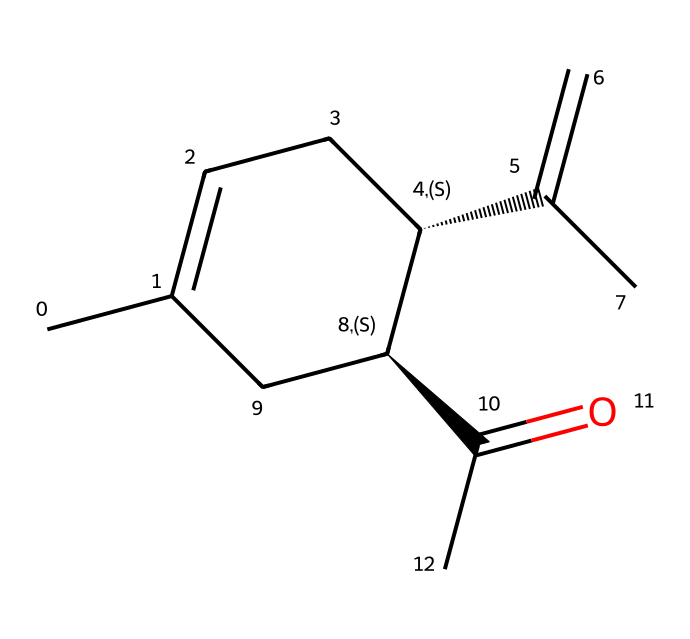What is the molecular formula of carvone? By analyzing the structure represented in the SMILES notation, we identify the various atoms present: there are 10 carbon (C) atoms, 12 hydrogen (H) atoms, and 1 oxygen (O) atom. Combining these gives the molecular formula C10H12O.
Answer: C10H12O How many chiral centers are present in carvone? By examining the molecular structure, we find two carbon atoms that are attached to four different groups, making them chiral centers. The presence of these two chiral centers indicates that carvone can exist as geometric isomers.
Answer: 2 What type of geometric isomerism is exhibited by carvone? The structure of carvone contains double bonds with restricted rotation, leading to cis/trans isomerism due to the different spatial arrangements of substituents around these double bonds.
Answer: cis/trans How many geometric isomers can carvone have? Since there are two chiral centers in carvone, the maximum number of stereoisomers can be calculated using the formula 2^n, where n is the number of chiral centers. In this case, there are 2^2 which equals 4 geometric isomers.
Answer: 4 What is the significance of the carbonyl group in carvone? The carbonyl group (C=O) contributes to the polarity and reactivity of carvone, influencing its interactions with other molecules, such as its aroma and flavor profile in caraway seeds.
Answer: reactivity What feature in the structure indicates potential for geometric isomerism? The presence of a double bond in the structure creates regions where rotation is restricted, allowing for different spatial arrangements or isomers to exist, specifically between the substituents on either side of the double bond.
Answer: double bond What is the impact of geometric isomerism on the properties of carvone? The different geometric arrangements of the isomers can lead to variations in physical and chemical properties such as boiling points, solubility, and even biological activity, influencing how carvone is perceived in flavor and fragrance applications.
Answer: variations in properties 